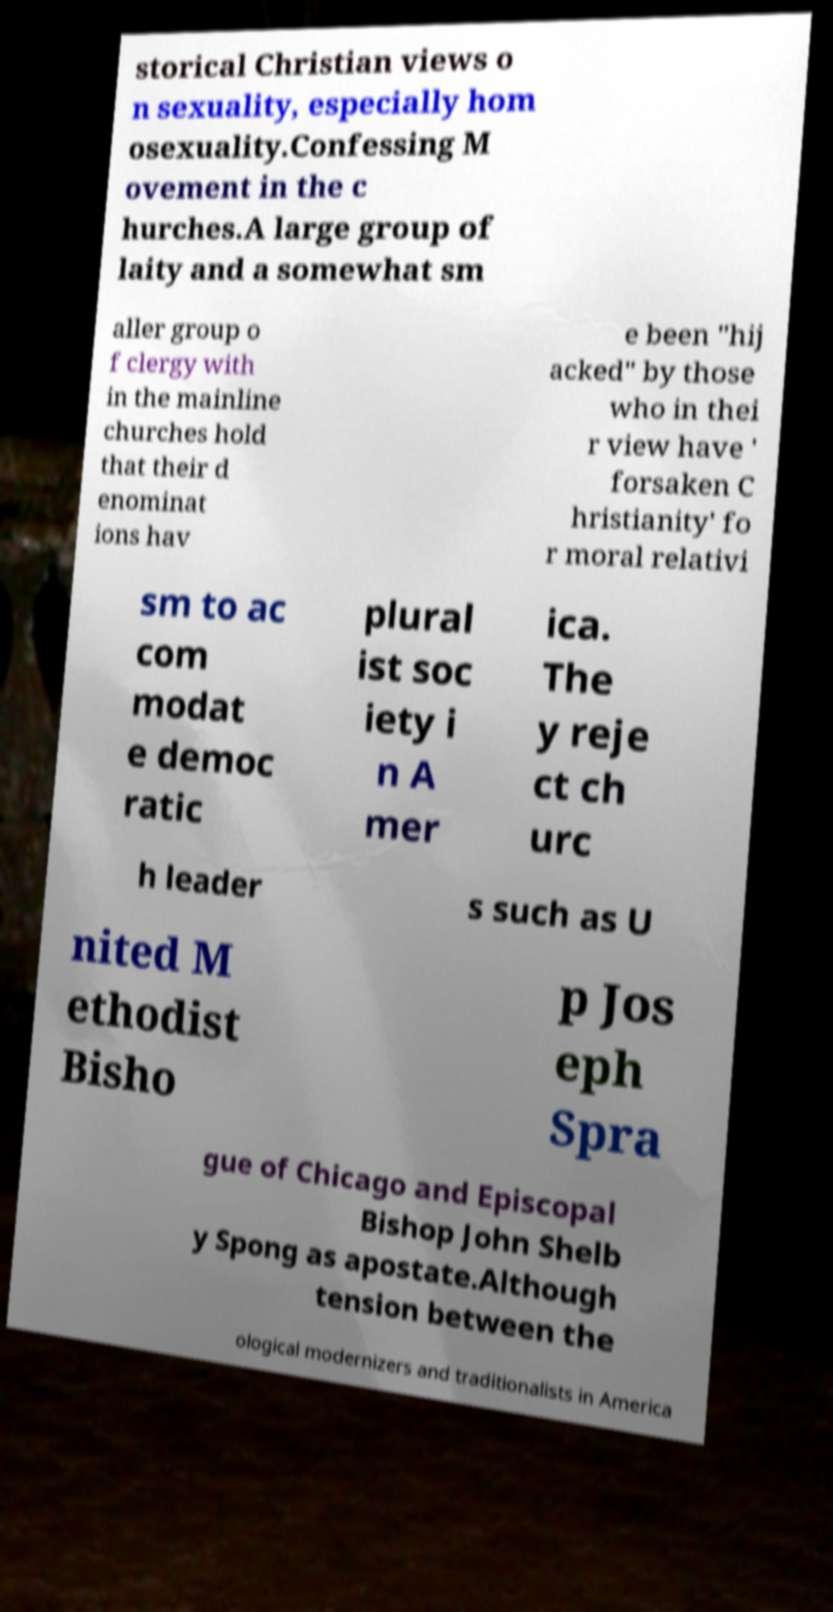Please identify and transcribe the text found in this image. storical Christian views o n sexuality, especially hom osexuality.Confessing M ovement in the c hurches.A large group of laity and a somewhat sm aller group o f clergy with in the mainline churches hold that their d enominat ions hav e been "hij acked" by those who in thei r view have ' forsaken C hristianity' fo r moral relativi sm to ac com modat e democ ratic plural ist soc iety i n A mer ica. The y reje ct ch urc h leader s such as U nited M ethodist Bisho p Jos eph Spra gue of Chicago and Episcopal Bishop John Shelb y Spong as apostate.Although tension between the ological modernizers and traditionalists in America 